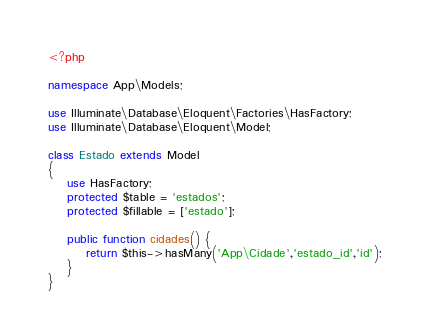<code> <loc_0><loc_0><loc_500><loc_500><_PHP_><?php

namespace App\Models;

use Illuminate\Database\Eloquent\Factories\HasFactory;
use Illuminate\Database\Eloquent\Model;

class Estado extends Model
{
    use HasFactory;
    protected $table = 'estados';
    protected $fillable = ['estado'];

    public function cidades() {
        return $this->hasMany('App\Cidade','estado_id','id');
    }
}
</code> 